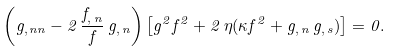Convert formula to latex. <formula><loc_0><loc_0><loc_500><loc_500>\left ( g _ { , \, n n } - 2 \, \frac { f _ { , \, n } } { f } \, g _ { , \, n } \right ) \left [ g ^ { 2 } f ^ { 2 } + 2 \, \eta ( \kappa f ^ { 2 } + g _ { , \, n } \, g _ { , \, s } ) \right ] = 0 .</formula> 